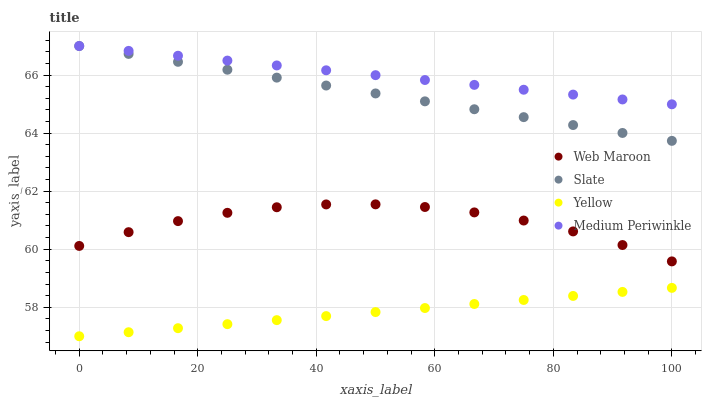Does Yellow have the minimum area under the curve?
Answer yes or no. Yes. Does Medium Periwinkle have the maximum area under the curve?
Answer yes or no. Yes. Does Slate have the minimum area under the curve?
Answer yes or no. No. Does Slate have the maximum area under the curve?
Answer yes or no. No. Is Medium Periwinkle the smoothest?
Answer yes or no. Yes. Is Web Maroon the roughest?
Answer yes or no. Yes. Is Slate the smoothest?
Answer yes or no. No. Is Slate the roughest?
Answer yes or no. No. Does Yellow have the lowest value?
Answer yes or no. Yes. Does Slate have the lowest value?
Answer yes or no. No. Does Slate have the highest value?
Answer yes or no. Yes. Does Web Maroon have the highest value?
Answer yes or no. No. Is Web Maroon less than Slate?
Answer yes or no. Yes. Is Medium Periwinkle greater than Yellow?
Answer yes or no. Yes. Does Medium Periwinkle intersect Slate?
Answer yes or no. Yes. Is Medium Periwinkle less than Slate?
Answer yes or no. No. Is Medium Periwinkle greater than Slate?
Answer yes or no. No. Does Web Maroon intersect Slate?
Answer yes or no. No. 